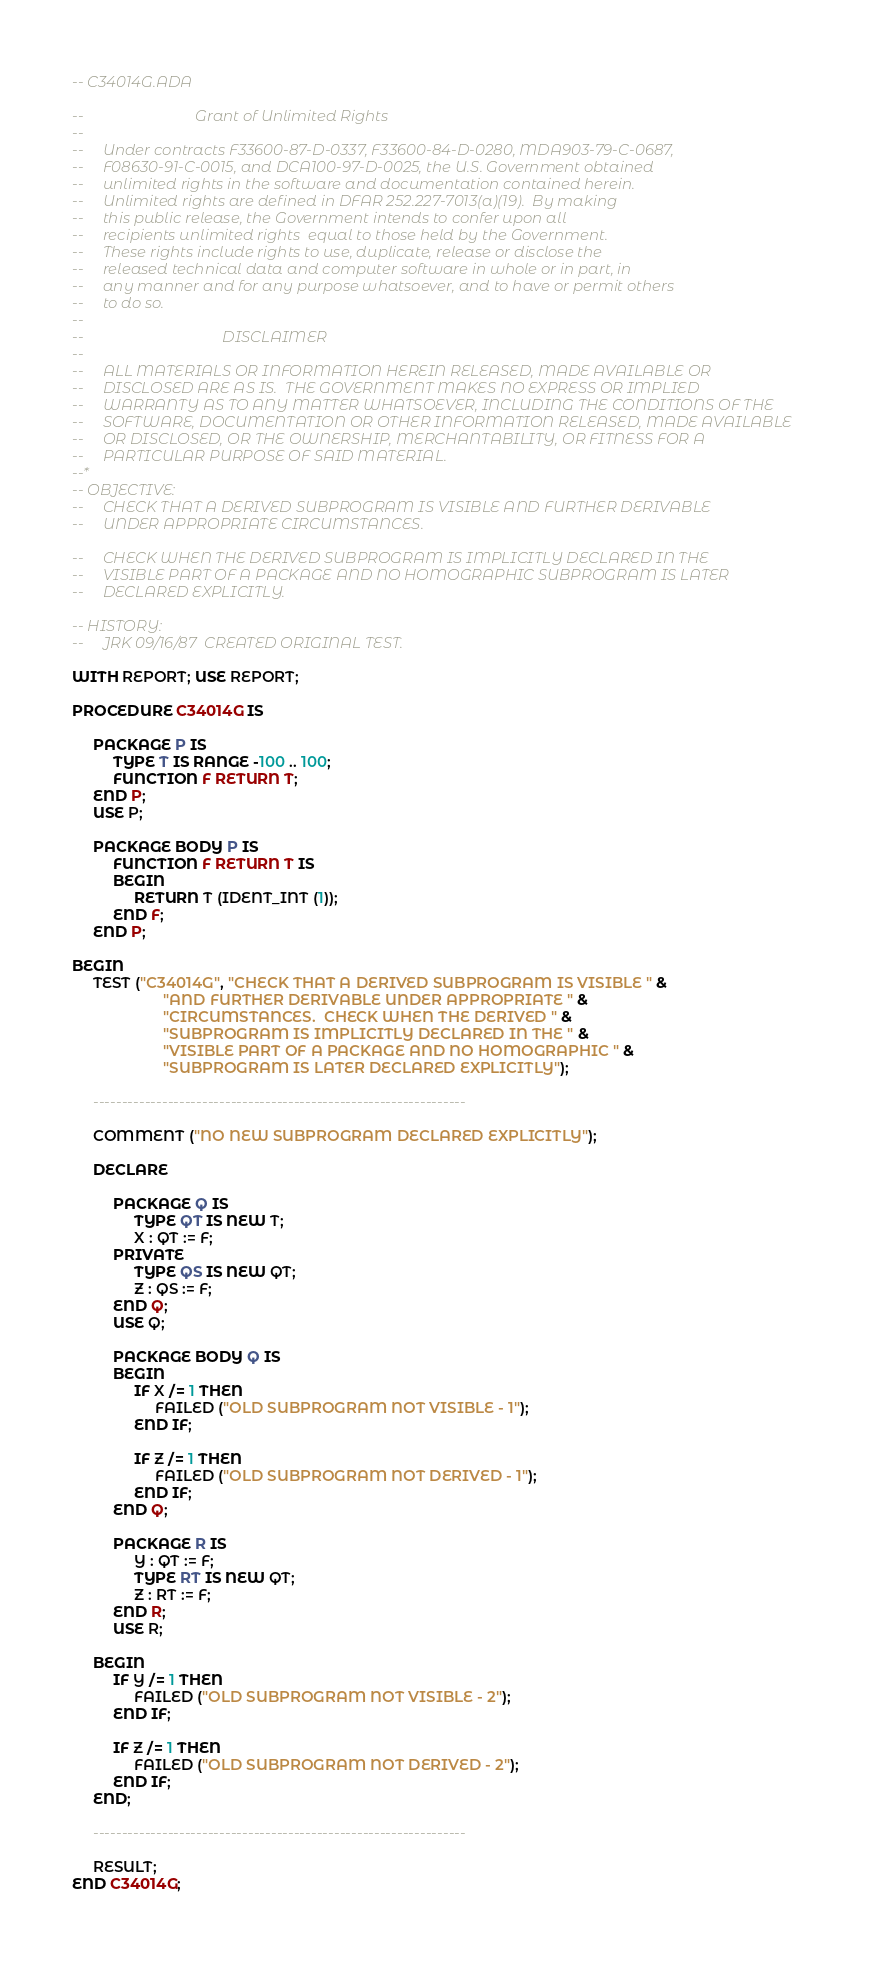<code> <loc_0><loc_0><loc_500><loc_500><_Ada_>-- C34014G.ADA

--                             Grant of Unlimited Rights
--
--     Under contracts F33600-87-D-0337, F33600-84-D-0280, MDA903-79-C-0687,
--     F08630-91-C-0015, and DCA100-97-D-0025, the U.S. Government obtained 
--     unlimited rights in the software and documentation contained herein.
--     Unlimited rights are defined in DFAR 252.227-7013(a)(19).  By making 
--     this public release, the Government intends to confer upon all 
--     recipients unlimited rights  equal to those held by the Government.  
--     These rights include rights to use, duplicate, release or disclose the 
--     released technical data and computer software in whole or in part, in 
--     any manner and for any purpose whatsoever, and to have or permit others 
--     to do so.
--
--                                    DISCLAIMER
--
--     ALL MATERIALS OR INFORMATION HEREIN RELEASED, MADE AVAILABLE OR
--     DISCLOSED ARE AS IS.  THE GOVERNMENT MAKES NO EXPRESS OR IMPLIED 
--     WARRANTY AS TO ANY MATTER WHATSOEVER, INCLUDING THE CONDITIONS OF THE
--     SOFTWARE, DOCUMENTATION OR OTHER INFORMATION RELEASED, MADE AVAILABLE 
--     OR DISCLOSED, OR THE OWNERSHIP, MERCHANTABILITY, OR FITNESS FOR A
--     PARTICULAR PURPOSE OF SAID MATERIAL.
--*
-- OBJECTIVE:
--     CHECK THAT A DERIVED SUBPROGRAM IS VISIBLE AND FURTHER DERIVABLE
--     UNDER APPROPRIATE CIRCUMSTANCES.

--     CHECK WHEN THE DERIVED SUBPROGRAM IS IMPLICITLY DECLARED IN THE
--     VISIBLE PART OF A PACKAGE AND NO HOMOGRAPHIC SUBPROGRAM IS LATER
--     DECLARED EXPLICITLY.

-- HISTORY:
--     JRK 09/16/87  CREATED ORIGINAL TEST.

WITH REPORT; USE REPORT;

PROCEDURE C34014G IS

     PACKAGE P IS
          TYPE T IS RANGE -100 .. 100;
          FUNCTION F RETURN T;
     END P;
     USE P;

     PACKAGE BODY P IS
          FUNCTION F RETURN T IS
          BEGIN
               RETURN T (IDENT_INT (1));
          END F;
     END P;

BEGIN
     TEST ("C34014G", "CHECK THAT A DERIVED SUBPROGRAM IS VISIBLE " &
                      "AND FURTHER DERIVABLE UNDER APPROPRIATE " &
                      "CIRCUMSTANCES.  CHECK WHEN THE DERIVED " &
                      "SUBPROGRAM IS IMPLICITLY DECLARED IN THE " &
                      "VISIBLE PART OF A PACKAGE AND NO HOMOGRAPHIC " &
                      "SUBPROGRAM IS LATER DECLARED EXPLICITLY");

     -----------------------------------------------------------------

     COMMENT ("NO NEW SUBPROGRAM DECLARED EXPLICITLY");

     DECLARE

          PACKAGE Q IS
               TYPE QT IS NEW T;
               X : QT := F;
          PRIVATE
               TYPE QS IS NEW QT;
               Z : QS := F;
          END Q;
          USE Q;

          PACKAGE BODY Q IS
          BEGIN
               IF X /= 1 THEN
                    FAILED ("OLD SUBPROGRAM NOT VISIBLE - 1");
               END IF;

               IF Z /= 1 THEN
                    FAILED ("OLD SUBPROGRAM NOT DERIVED - 1");
               END IF;
          END Q;

          PACKAGE R IS
               Y : QT := F;
               TYPE RT IS NEW QT;
               Z : RT := F;
          END R;
          USE R;

     BEGIN
          IF Y /= 1 THEN
               FAILED ("OLD SUBPROGRAM NOT VISIBLE - 2");
          END IF;

          IF Z /= 1 THEN
               FAILED ("OLD SUBPROGRAM NOT DERIVED - 2");
          END IF;
     END;

     -----------------------------------------------------------------

     RESULT;
END C34014G;
</code> 